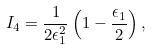<formula> <loc_0><loc_0><loc_500><loc_500>I _ { 4 } = \frac { 1 } { 2 \epsilon _ { 1 } ^ { 2 } } \left ( 1 - \frac { \epsilon _ { 1 } } { 2 } \right ) ,</formula> 